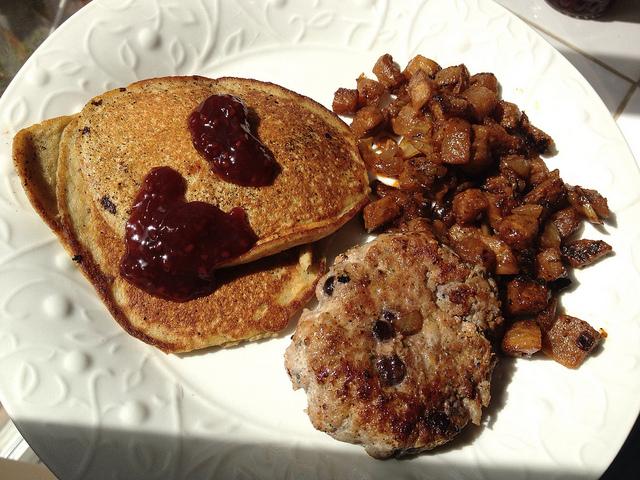What fruit is on the bread?
Quick response, please. Strawberry. Where is the pancakes placed?
Answer briefly. Left. What kind of foods can be seen?
Answer briefly. Breakfast. Are these breakfast foods?
Concise answer only. Yes. What is sticking out from on top of the bun?
Answer briefly. Jelly. 